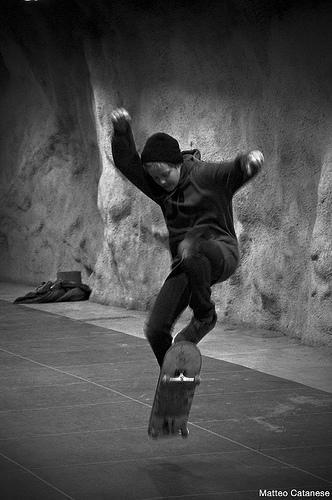How many people are in the picture?
Give a very brief answer. 1. How many skateboards are in the picture?
Give a very brief answer. 1. 